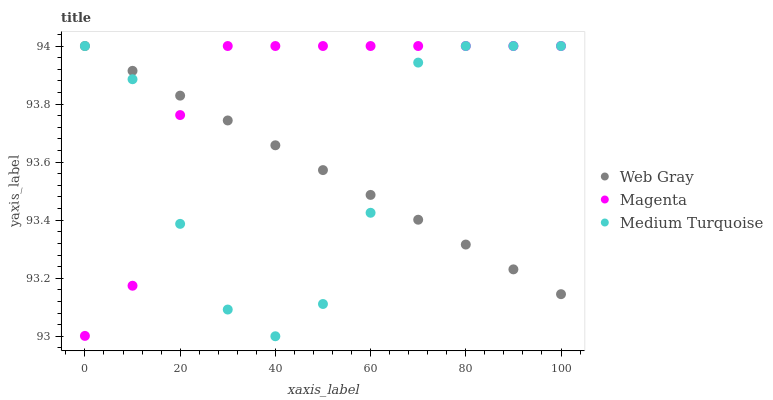Does Web Gray have the minimum area under the curve?
Answer yes or no. Yes. Does Magenta have the maximum area under the curve?
Answer yes or no. Yes. Does Medium Turquoise have the minimum area under the curve?
Answer yes or no. No. Does Medium Turquoise have the maximum area under the curve?
Answer yes or no. No. Is Web Gray the smoothest?
Answer yes or no. Yes. Is Medium Turquoise the roughest?
Answer yes or no. Yes. Is Medium Turquoise the smoothest?
Answer yes or no. No. Is Web Gray the roughest?
Answer yes or no. No. Does Medium Turquoise have the lowest value?
Answer yes or no. Yes. Does Web Gray have the lowest value?
Answer yes or no. No. Does Medium Turquoise have the highest value?
Answer yes or no. Yes. Does Medium Turquoise intersect Magenta?
Answer yes or no. Yes. Is Medium Turquoise less than Magenta?
Answer yes or no. No. Is Medium Turquoise greater than Magenta?
Answer yes or no. No. 